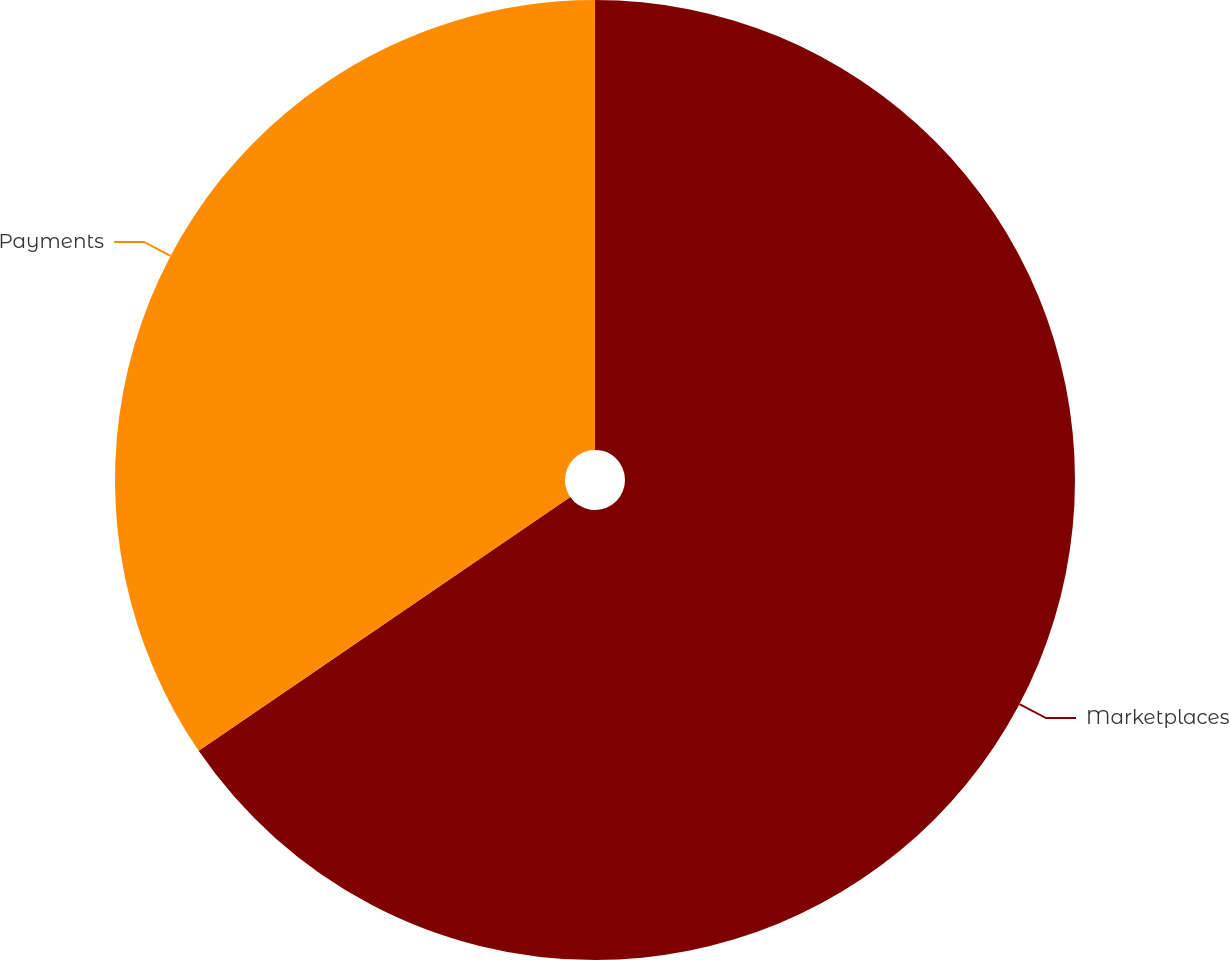Convert chart to OTSL. <chart><loc_0><loc_0><loc_500><loc_500><pie_chart><fcel>Marketplaces<fcel>Payments<nl><fcel>65.46%<fcel>34.54%<nl></chart> 